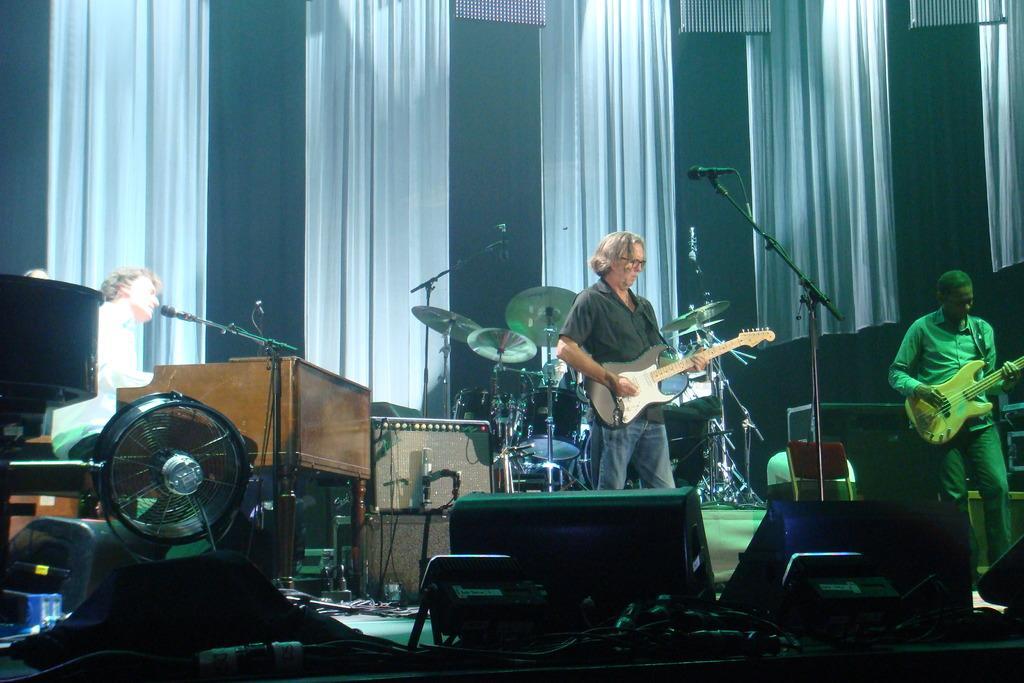In one or two sentences, can you explain what this image depicts? In the image there is a man playing guitar and around him there are many other instruments and two other people also playing some music, in the background there are curtains. 